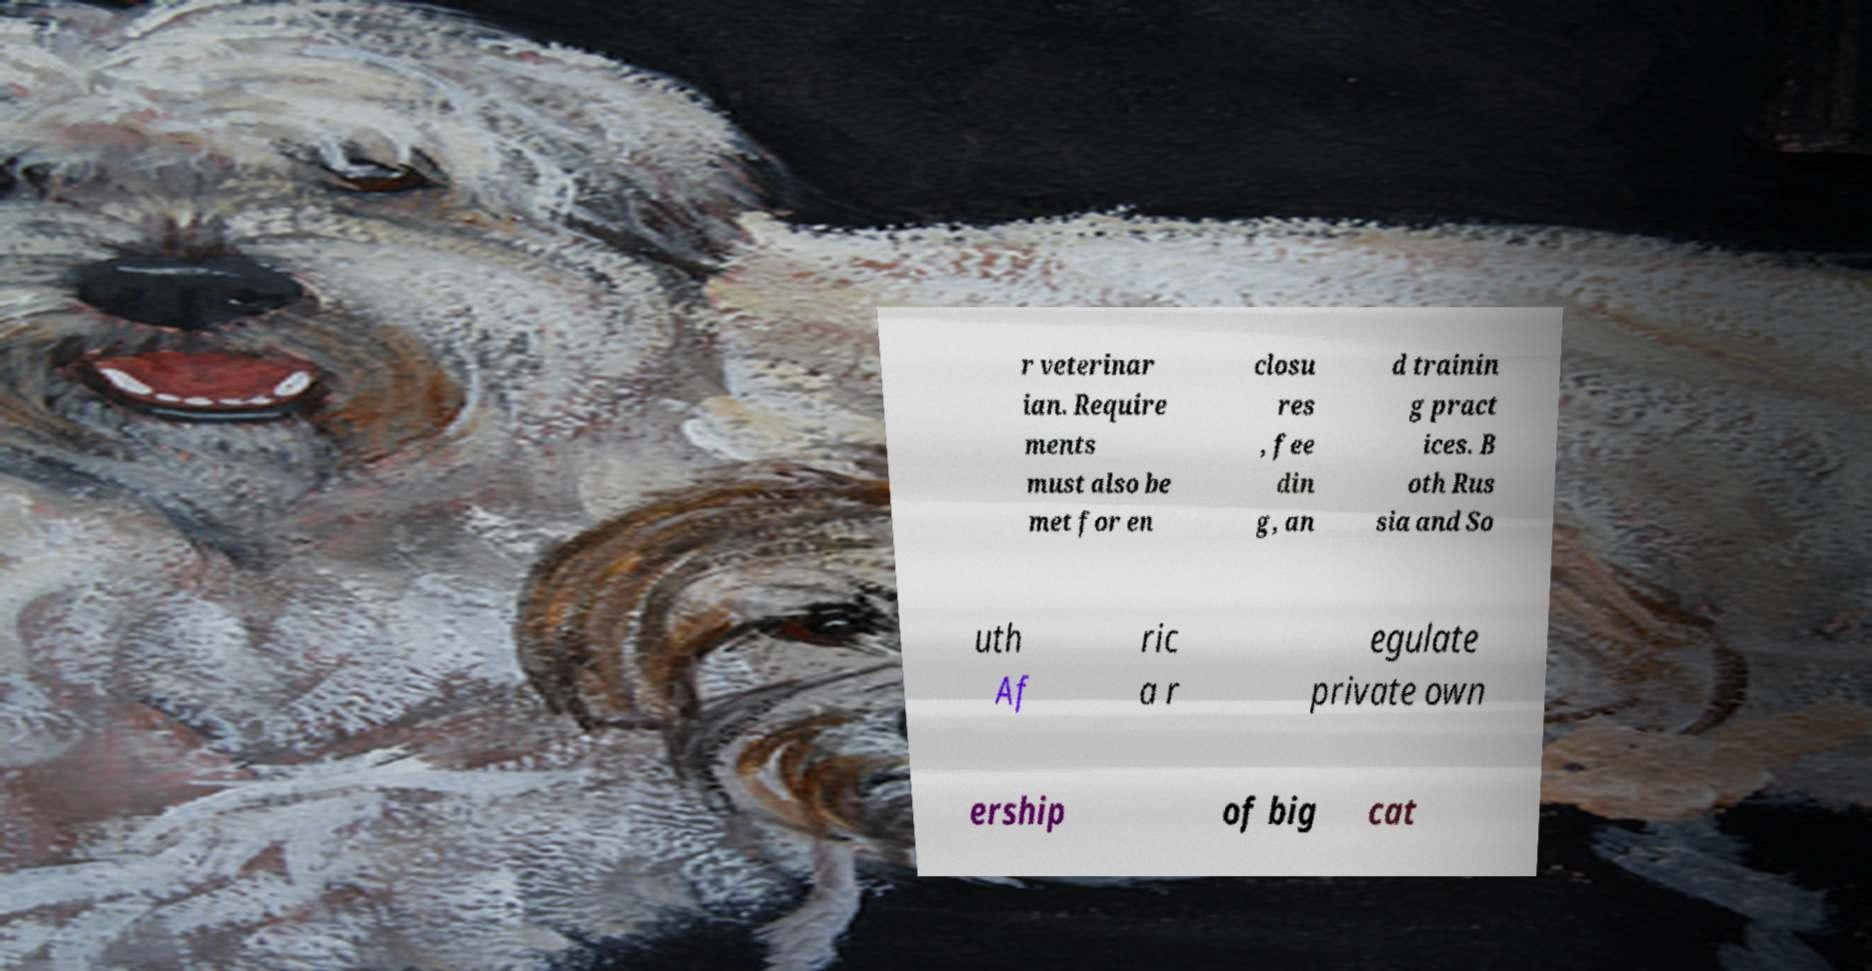Can you read and provide the text displayed in the image?This photo seems to have some interesting text. Can you extract and type it out for me? r veterinar ian. Require ments must also be met for en closu res , fee din g, an d trainin g pract ices. B oth Rus sia and So uth Af ric a r egulate private own ership of big cat 